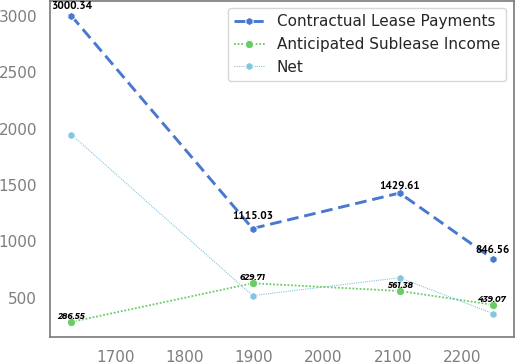<chart> <loc_0><loc_0><loc_500><loc_500><line_chart><ecel><fcel>Contractual Lease Payments<fcel>Anticipated Sublease Income<fcel>Net<nl><fcel>1636.95<fcel>3000.34<fcel>286.55<fcel>1948.02<nl><fcel>1897.67<fcel>1115.03<fcel>629.71<fcel>520.18<nl><fcel>2109.44<fcel>1429.61<fcel>561.38<fcel>678.83<nl><fcel>2243.45<fcel>846.56<fcel>439.07<fcel>361.53<nl></chart> 